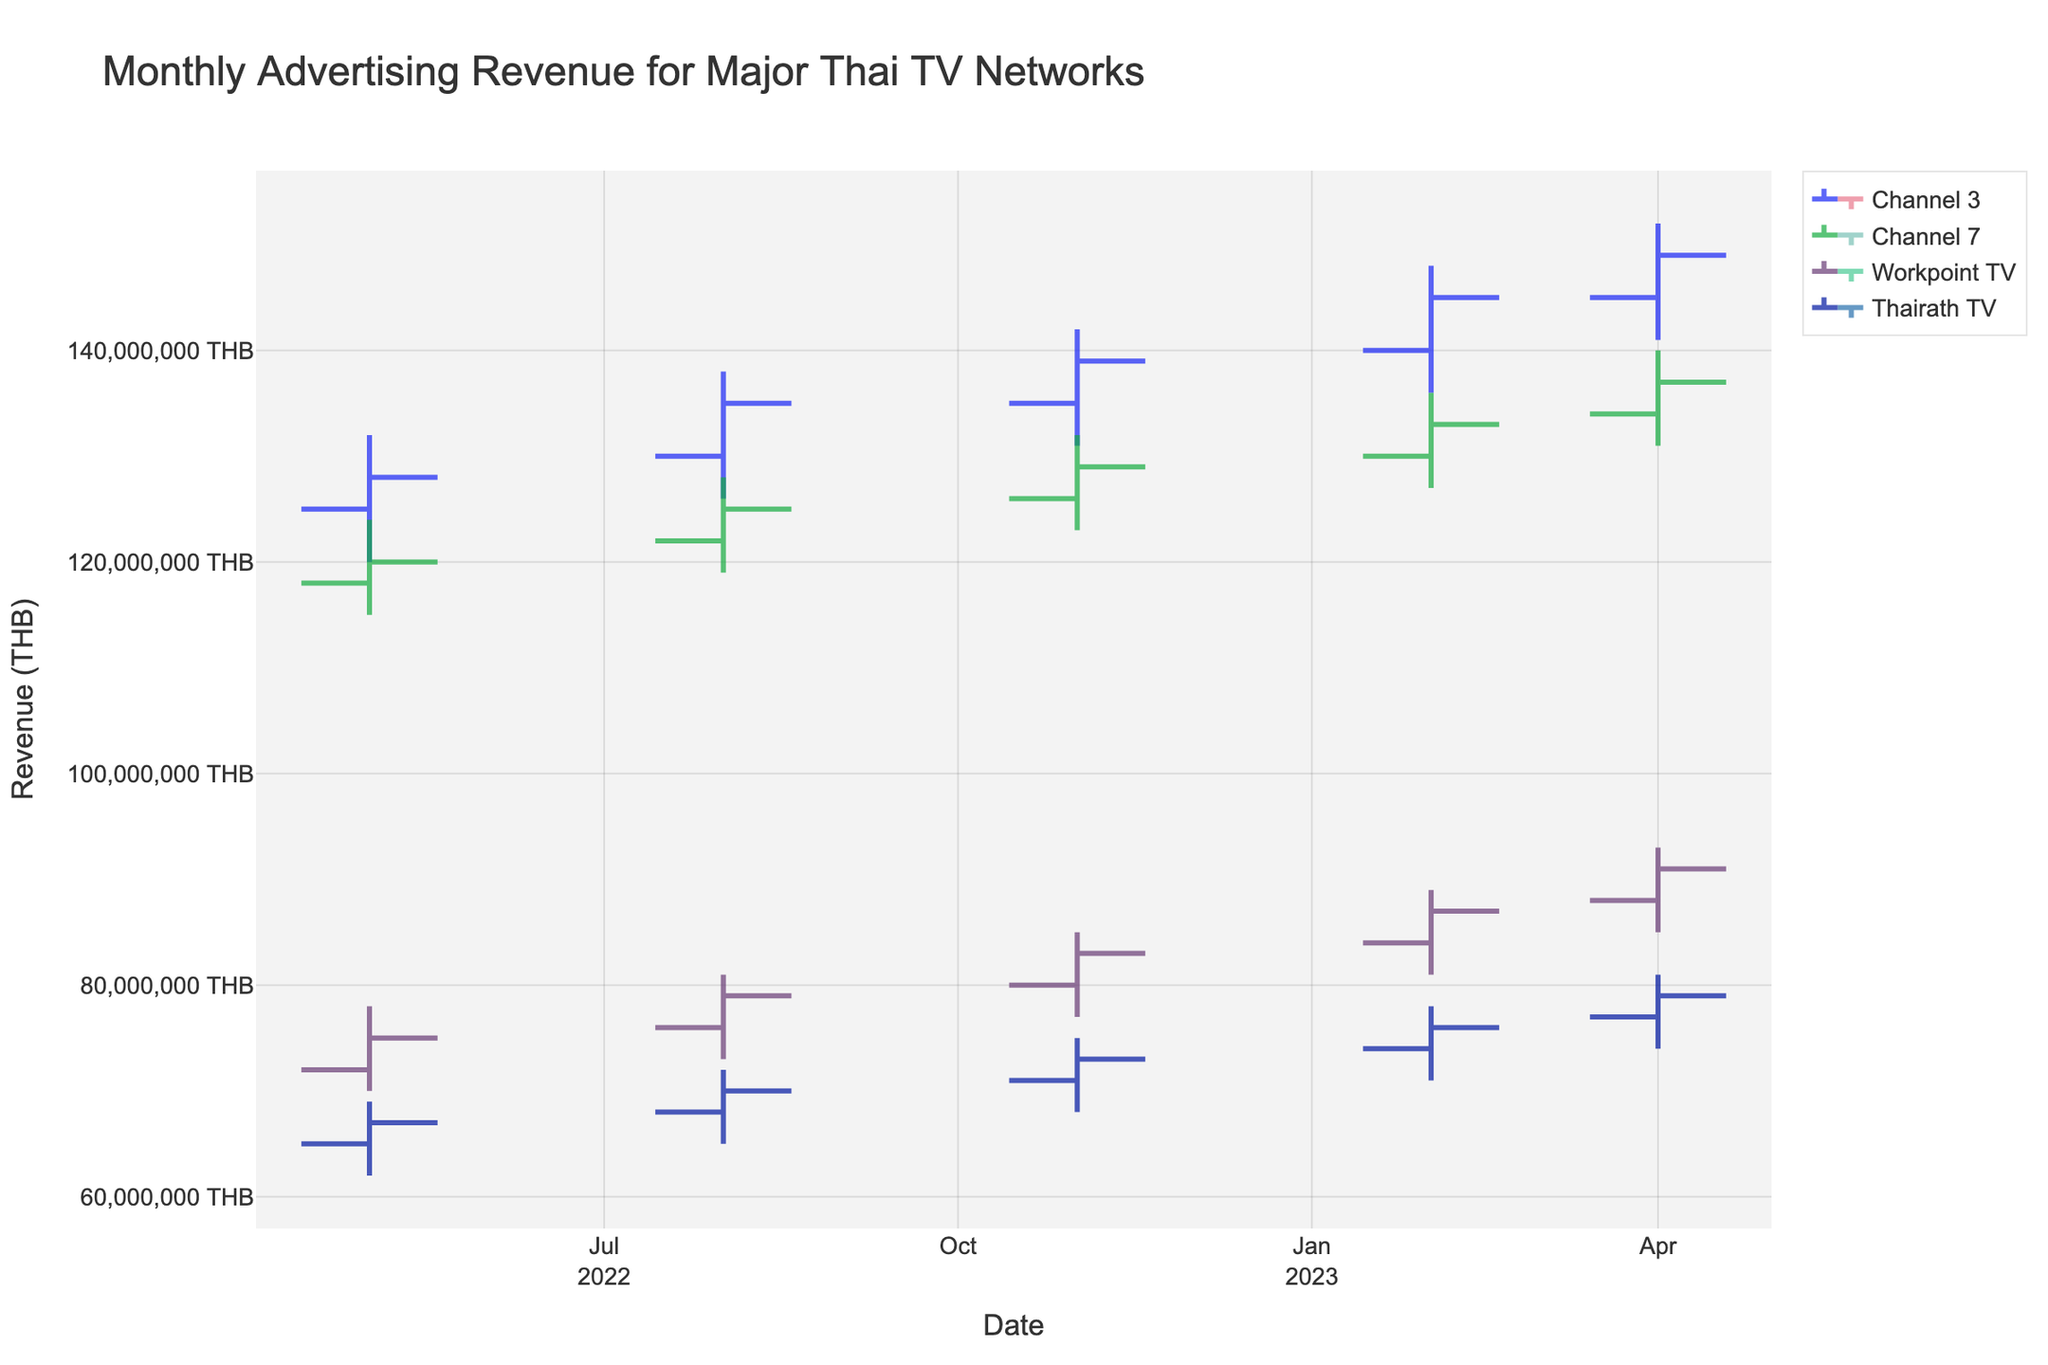Which network had the highest revenue in April 2023? Look at the Close value for April 2023. Channel 3 has the highest value at 149,000,000 THB.
Answer: Channel 3 Which month shows the highest average advertising revenue across all networks? Calculate the average Close value for each month. The month with the highest average is February 2023 with an average of 135,750,000 THB.
Answer: February 2023 Did Channel 7's revenue increase or decrease from February 2023 to April 2023? Compare the Close values of Channel 7 in February 2023 (133,000,000 THB) and April 2023 (137,000,000 THB). The revenue increased.
Answer: Increased Comparing Workpoint TV and Thairath TV, which network experienced the higher growth rate from May 2022 to April 2023? Calculate the growth rate for each: Workpoint TV's growth = (91,000,000 - 75,000,000) / 75,000,000 = 21.33%, Thairath TV's growth = (79,000,000 - 67,000,000) / 67,000,000 = 17.91%. Workpoint TV had a higher growth rate.
Answer: Workpoint TV Over the entire period shown, which network had the smallest range of monthly revenue values? Calculate the range (High - Low) for each network: Channel 3: 32,000,000, Channel 7: 25,000,000, Workpoint TV: 23,000,000, Thairath TV: 19,000,000. Thairath TV had the smallest range.
Answer: Thairath TV Did any network show a month where the revenue decreased from the opening to the closing value? Check for any month where Close < Open. For May 2022, all networks had increasing or constant values.
Answer: No Which network had the highest revenue increase between May 2022 and August 2022? Calculate the increase: Channel 3 (135,000,000 - 128,000,000), Channel 7 (125,000,000 - 120,000,000), Workpoint TV (79,000,000 - 75,000,000), Thairath TV (70,000,000 - 67,000,000). Channel 3 had the highest increase by 7,000,000 THB.
Answer: Channel 3 What is the median Close value for Channel 3 over the recorded months? Order Close values and find the middle one. For Channel 3: 128,000,000, 135,000,000, 139,000,000, 145,000,000, 149,000,000. The middle value is 139,000,000 THB.
Answer: 139,000,000 THB 